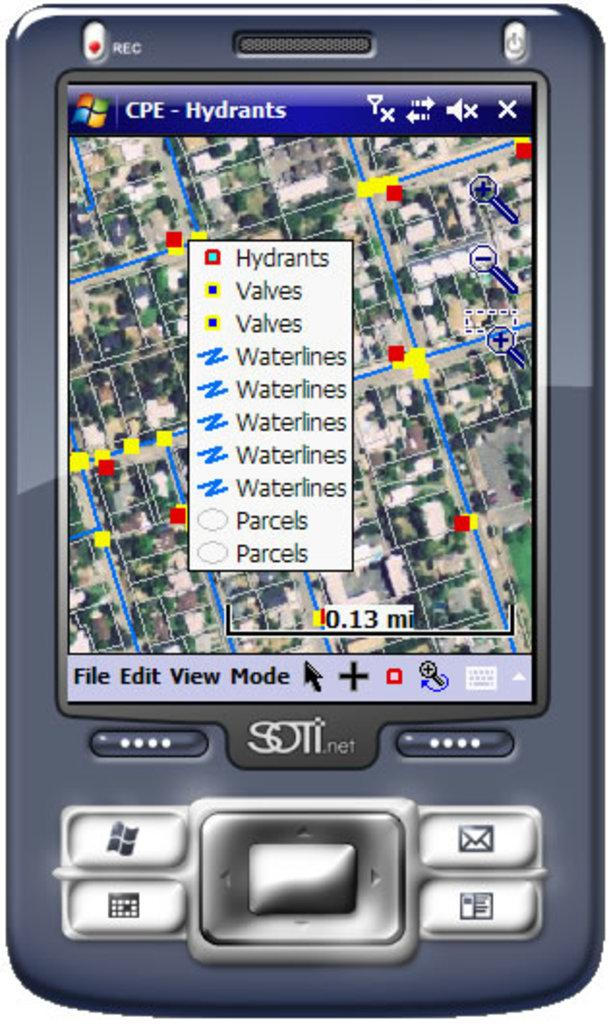<image>
Create a compact narrative representing the image presented. Screen of a device that says Hydrants on the screen. 